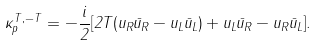Convert formula to latex. <formula><loc_0><loc_0><loc_500><loc_500>\kappa ^ { T , - T } _ { p } = - \frac { i } { 2 } [ 2 T ( u _ { R } { \bar { u } } _ { R } - u _ { L } { \bar { u } } _ { L } ) + u _ { L } { \bar { u } } _ { R } - u _ { R } { \bar { u } } _ { L } ] .</formula> 